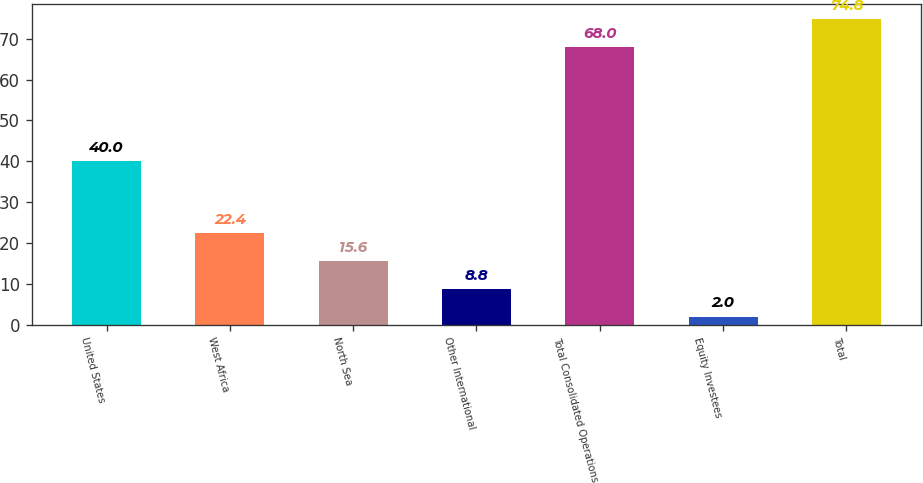Convert chart to OTSL. <chart><loc_0><loc_0><loc_500><loc_500><bar_chart><fcel>United States<fcel>West Africa<fcel>North Sea<fcel>Other International<fcel>Total Consolidated Operations<fcel>Equity Investees<fcel>Total<nl><fcel>40<fcel>22.4<fcel>15.6<fcel>8.8<fcel>68<fcel>2<fcel>74.8<nl></chart> 